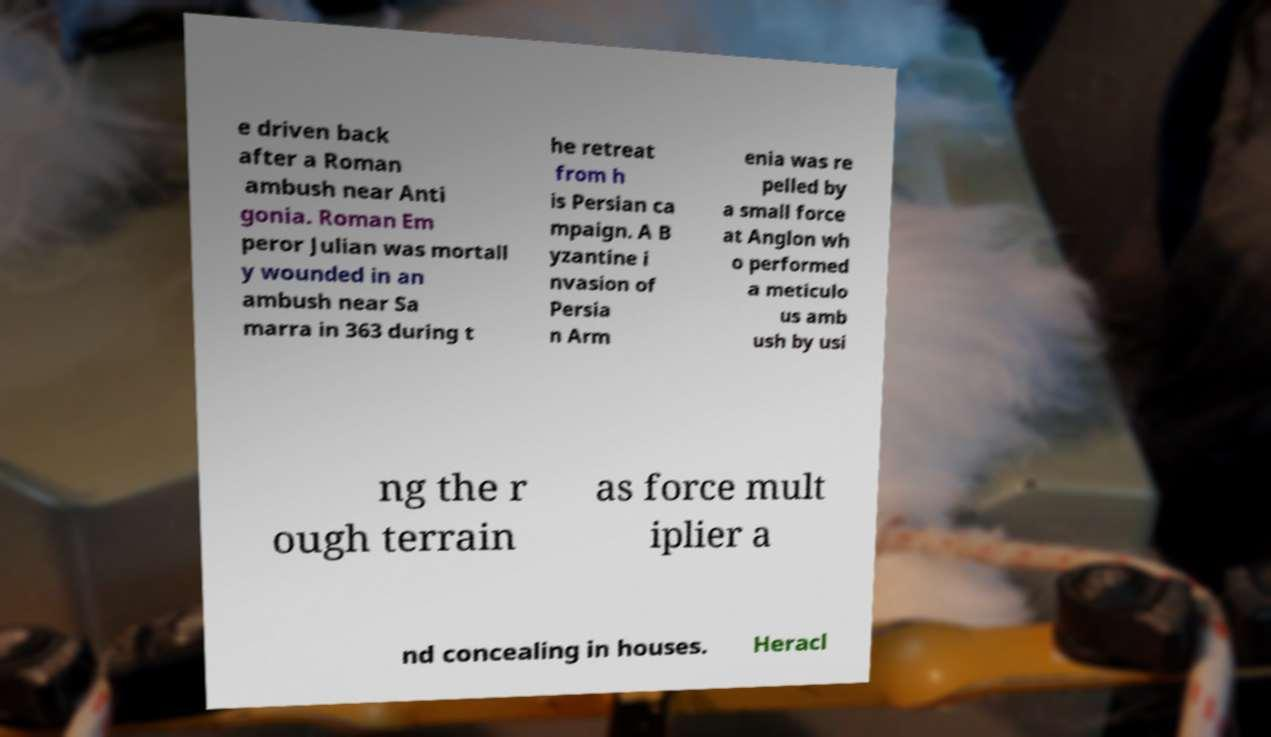Please read and relay the text visible in this image. What does it say? e driven back after a Roman ambush near Anti gonia. Roman Em peror Julian was mortall y wounded in an ambush near Sa marra in 363 during t he retreat from h is Persian ca mpaign. A B yzantine i nvasion of Persia n Arm enia was re pelled by a small force at Anglon wh o performed a meticulo us amb ush by usi ng the r ough terrain as force mult iplier a nd concealing in houses. Heracl 